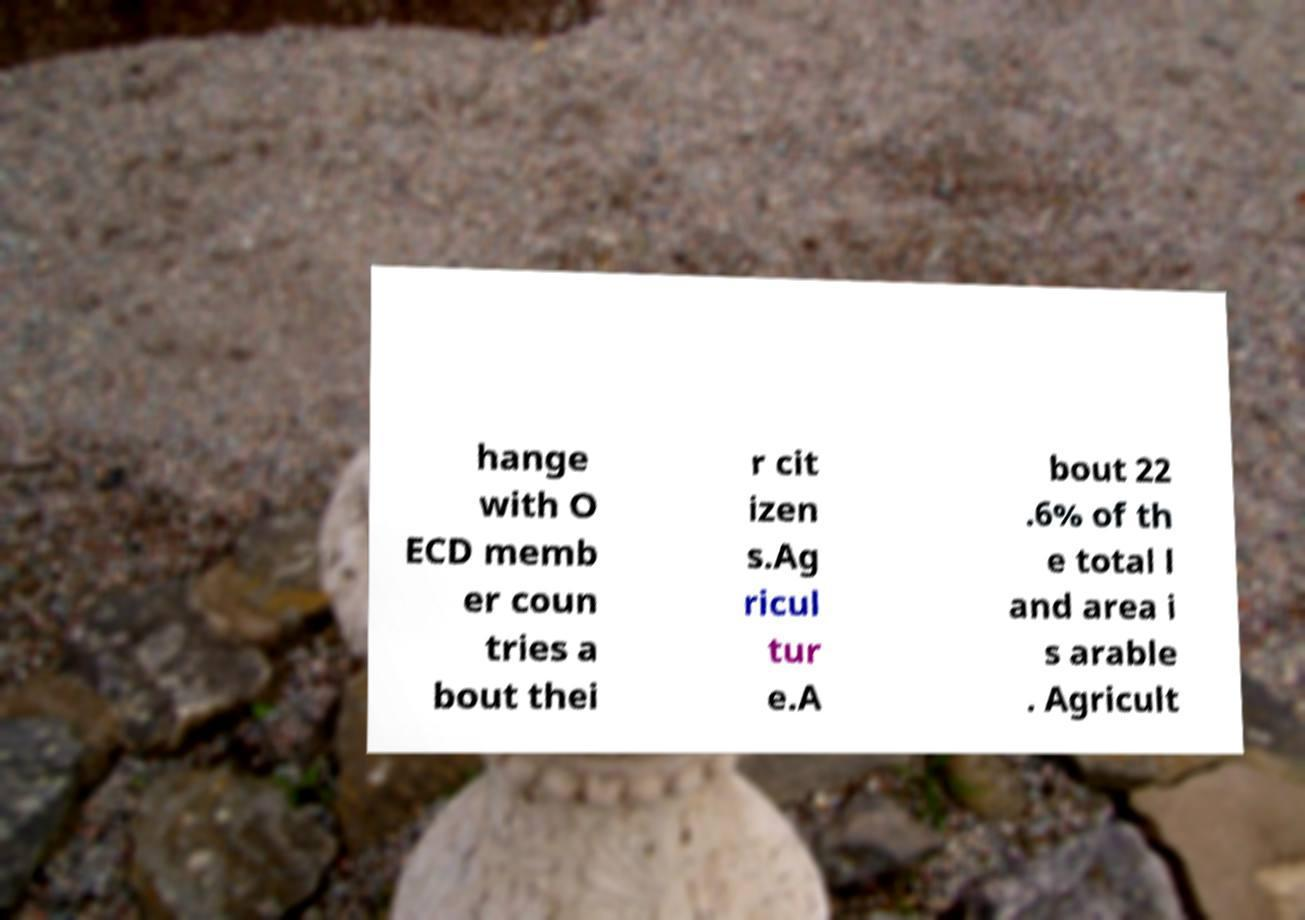Please identify and transcribe the text found in this image. hange with O ECD memb er coun tries a bout thei r cit izen s.Ag ricul tur e.A bout 22 .6% of th e total l and area i s arable . Agricult 